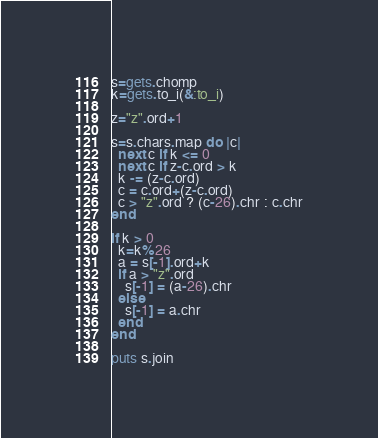Convert code to text. <code><loc_0><loc_0><loc_500><loc_500><_Ruby_>s=gets.chomp
k=gets.to_i(&:to_i)

z="z".ord+1

s=s.chars.map do |c|
  next c if k <= 0
  next c if z-c.ord > k
  k -= (z-c.ord)
  c = c.ord+(z-c.ord)
  c > "z".ord ? (c-26).chr : c.chr
end

if k > 0
  k=k%26
  a = s[-1].ord+k
  if a > "z".ord
    s[-1] = (a-26).chr
  else
    s[-1] = a.chr
  end
end

puts s.join

</code> 